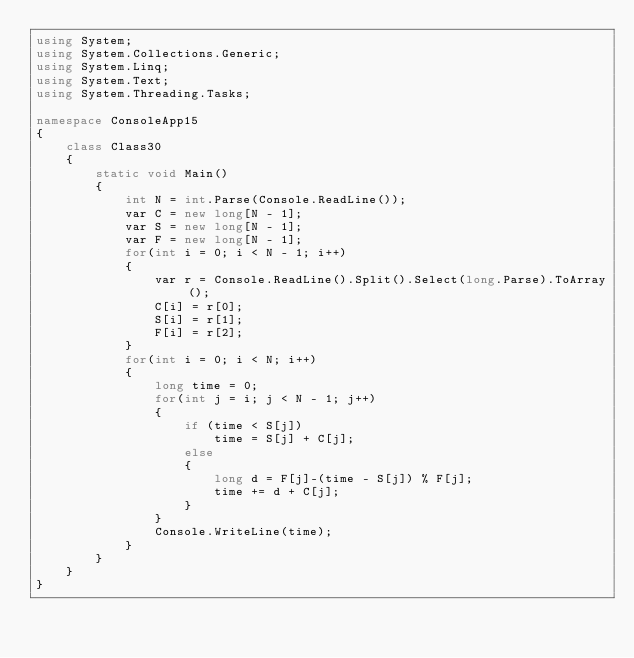Convert code to text. <code><loc_0><loc_0><loc_500><loc_500><_C#_>using System;
using System.Collections.Generic;
using System.Linq;
using System.Text;
using System.Threading.Tasks;

namespace ConsoleApp15
{
    class Class30
    {
        static void Main()
        {
            int N = int.Parse(Console.ReadLine());
            var C = new long[N - 1];
            var S = new long[N - 1];
            var F = new long[N - 1];
            for(int i = 0; i < N - 1; i++)
            {
                var r = Console.ReadLine().Split().Select(long.Parse).ToArray();
                C[i] = r[0];
                S[i] = r[1];
                F[i] = r[2];
            }
            for(int i = 0; i < N; i++)
            {
                long time = 0;
                for(int j = i; j < N - 1; j++)
                {
                    if (time < S[j])
                        time = S[j] + C[j];
                    else
                    {
                        long d = F[j]-(time - S[j]) % F[j];
                        time += d + C[j];
                    }
                }
                Console.WriteLine(time);
            }
        }
    }
}
</code> 